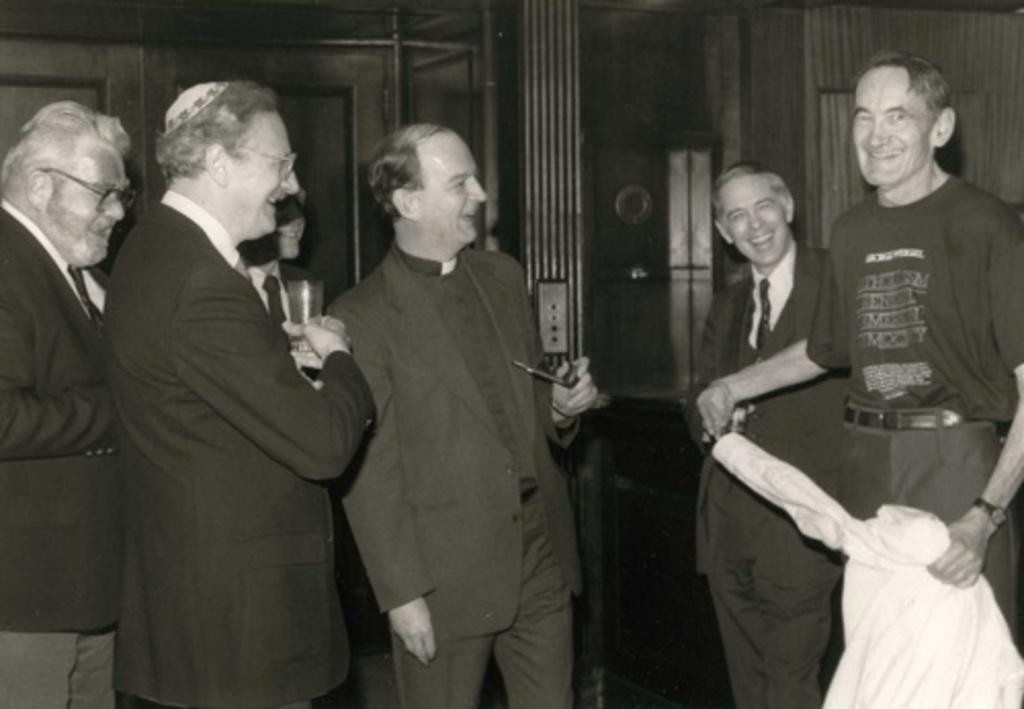What is happening in the image? There is a group of people standing in the image. Can you describe what one person is holding? One person is holding a glass. Are there any other people visible in the image besides the group? Yes, there are other people visible in the background. What is the color scheme of the image? The image is in black and white. What story is being told by the people in the image? There is no story being told by the people in the image; it is a static photograph. 